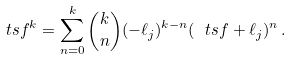Convert formula to latex. <formula><loc_0><loc_0><loc_500><loc_500>\ t s f ^ { k } = \sum _ { n = 0 } ^ { k } \binom { k } { n } ( - \ell _ { j } ) ^ { k - n } ( \ t s f + \ell _ { j } ) ^ { n } \, .</formula> 